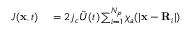Convert formula to latex. <formula><loc_0><loc_0><loc_500><loc_500>\begin{array} { r l } { J ( x , t ) } & = 2 j _ { c } \tilde { U } ( t ) \sum _ { i = 1 } ^ { N _ { p } } \chi _ { a } ( | x - R _ { i } | ) } \end{array}</formula> 